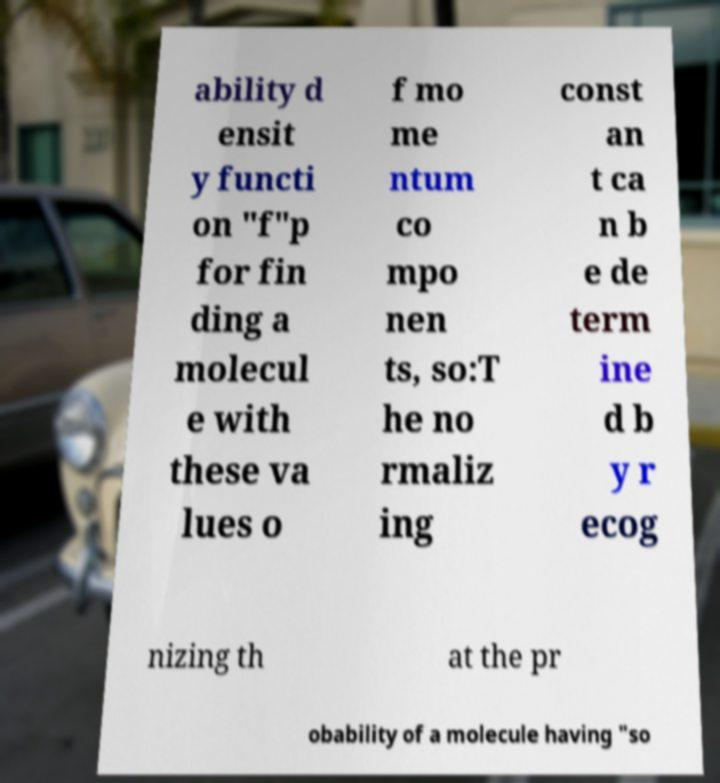Could you extract and type out the text from this image? ability d ensit y functi on "f"p for fin ding a molecul e with these va lues o f mo me ntum co mpo nen ts, so:T he no rmaliz ing const an t ca n b e de term ine d b y r ecog nizing th at the pr obability of a molecule having "so 